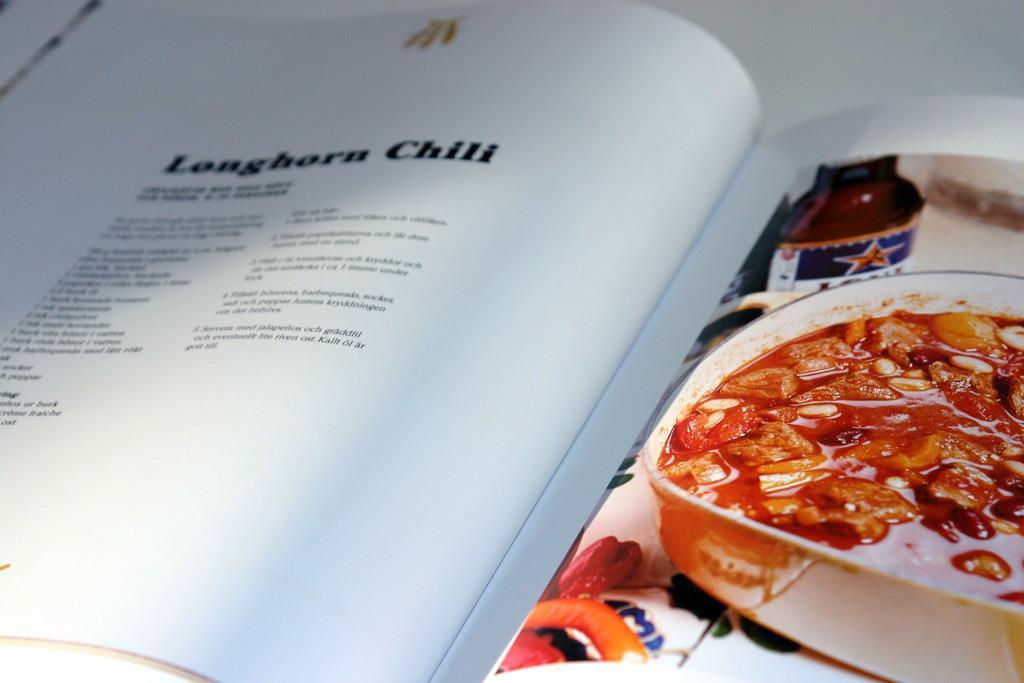How would you summarize this image in a sentence or two? In this image we can see a recipe book placed on the table. 